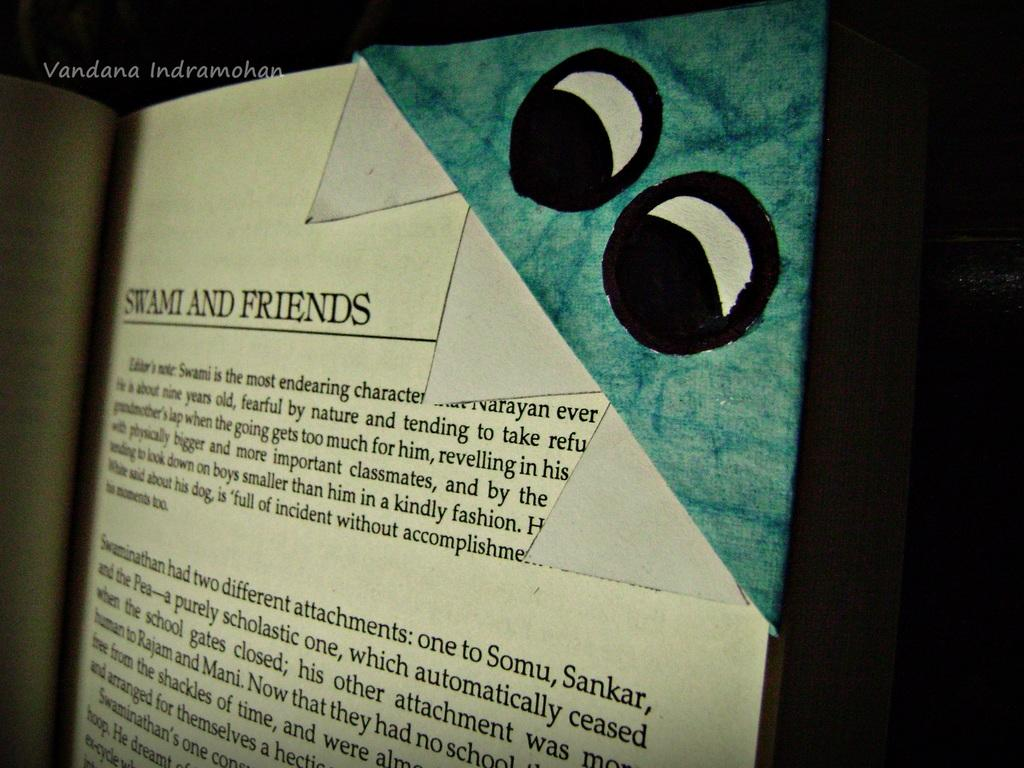<image>
Give a short and clear explanation of the subsequent image. a page in a book that is titled 'swami and friends' 